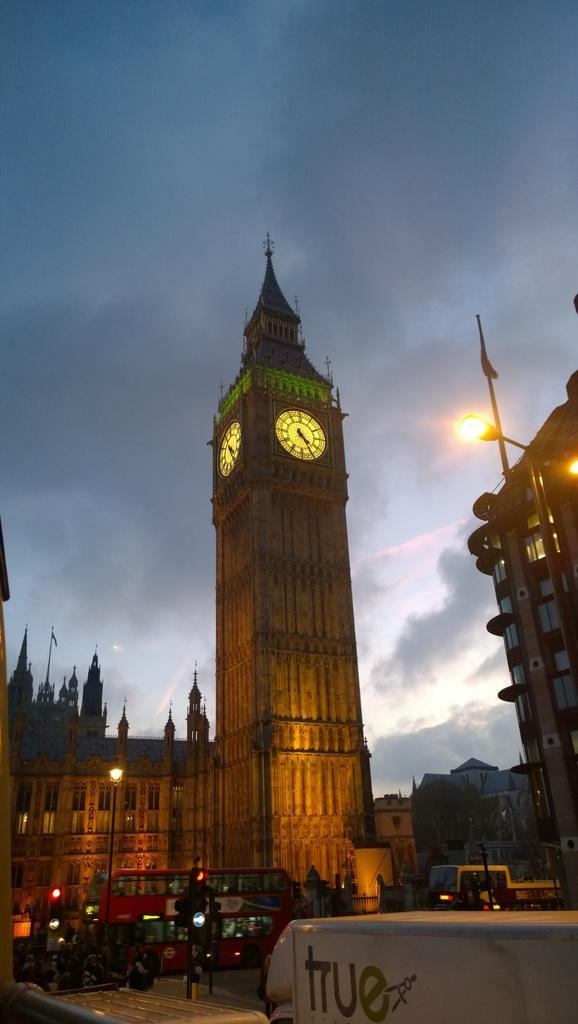Describe this image in one or two sentences. In this picture I can see vehicles on the road, there are buildings, there is a clock tower, there are poles, lights, and in the background there is the sky. 